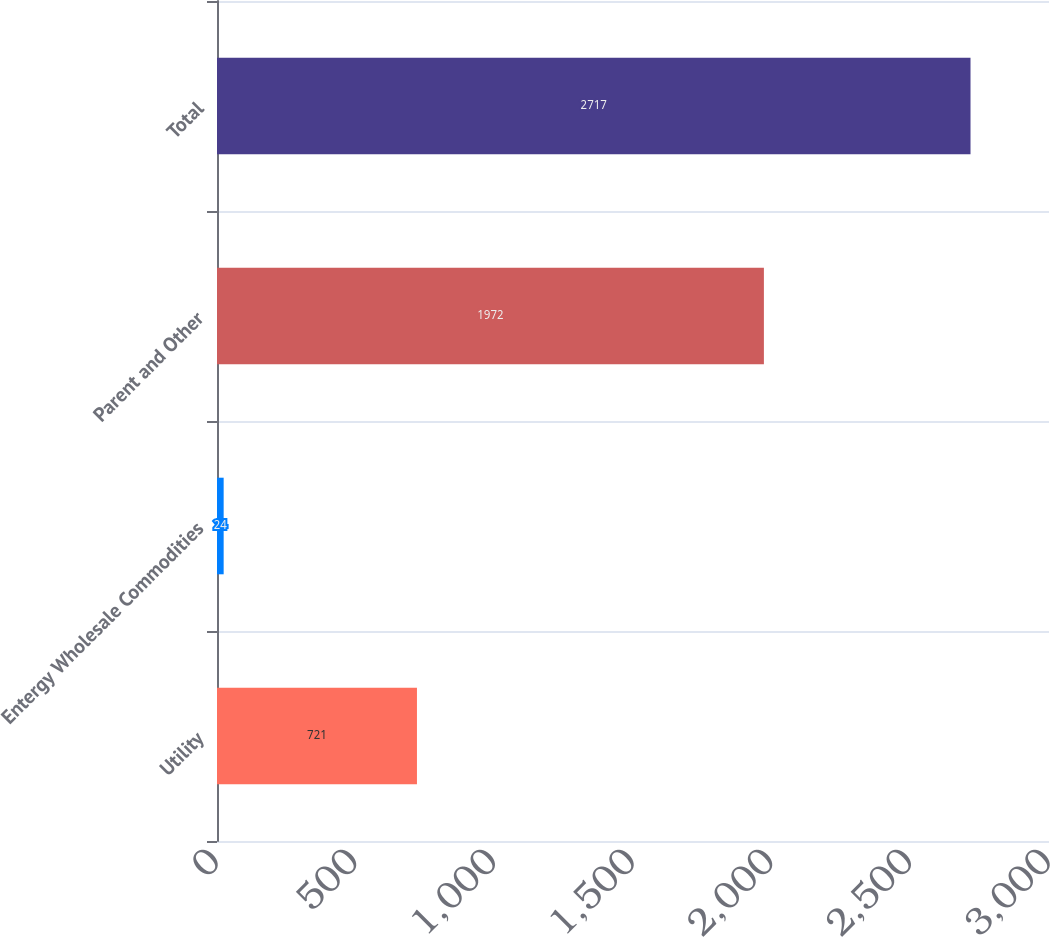Convert chart. <chart><loc_0><loc_0><loc_500><loc_500><bar_chart><fcel>Utility<fcel>Entergy Wholesale Commodities<fcel>Parent and Other<fcel>Total<nl><fcel>721<fcel>24<fcel>1972<fcel>2717<nl></chart> 